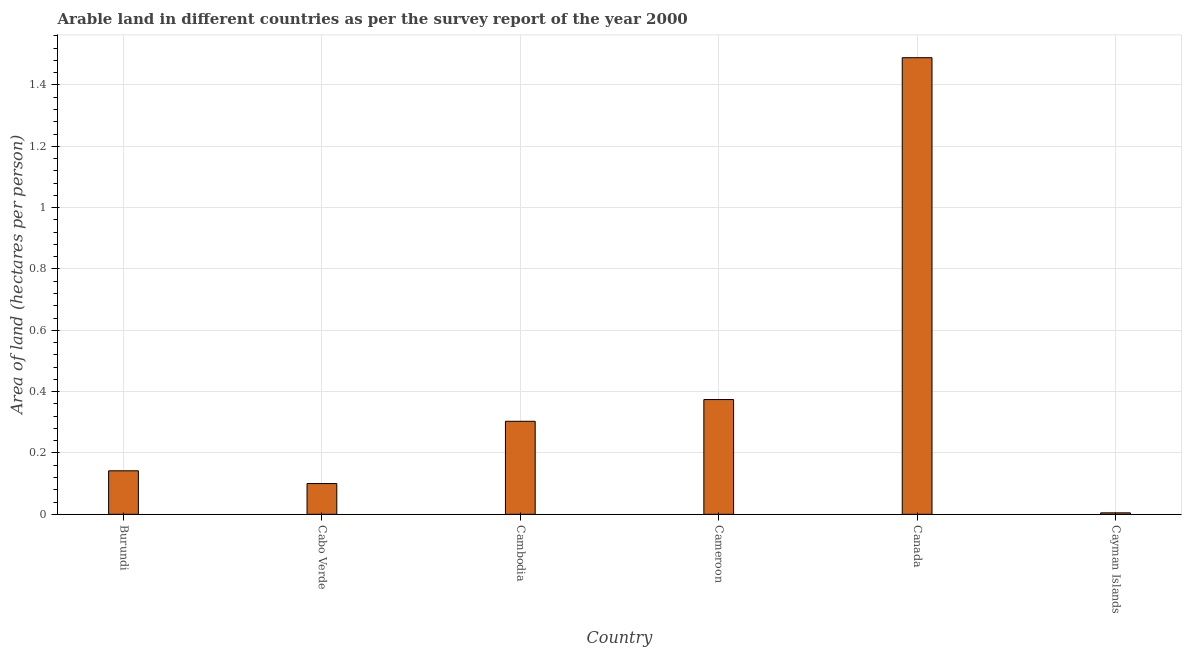Does the graph contain grids?
Keep it short and to the point. Yes. What is the title of the graph?
Offer a terse response. Arable land in different countries as per the survey report of the year 2000. What is the label or title of the X-axis?
Give a very brief answer. Country. What is the label or title of the Y-axis?
Your answer should be very brief. Area of land (hectares per person). What is the area of arable land in Cayman Islands?
Make the answer very short. 0. Across all countries, what is the maximum area of arable land?
Your response must be concise. 1.49. Across all countries, what is the minimum area of arable land?
Your answer should be very brief. 0. In which country was the area of arable land minimum?
Make the answer very short. Cayman Islands. What is the sum of the area of arable land?
Provide a short and direct response. 2.41. What is the difference between the area of arable land in Burundi and Cameroon?
Offer a very short reply. -0.23. What is the average area of arable land per country?
Offer a very short reply. 0.4. What is the median area of arable land?
Your answer should be compact. 0.22. In how many countries, is the area of arable land greater than 0.2 hectares per person?
Provide a short and direct response. 3. What is the ratio of the area of arable land in Cameroon to that in Canada?
Keep it short and to the point. 0.25. Is the area of arable land in Cambodia less than that in Cameroon?
Your response must be concise. Yes. Is the difference between the area of arable land in Burundi and Canada greater than the difference between any two countries?
Your response must be concise. No. What is the difference between the highest and the second highest area of arable land?
Ensure brevity in your answer.  1.11. Is the sum of the area of arable land in Cabo Verde and Cambodia greater than the maximum area of arable land across all countries?
Offer a very short reply. No. What is the difference between the highest and the lowest area of arable land?
Give a very brief answer. 1.48. Are all the bars in the graph horizontal?
Make the answer very short. No. Are the values on the major ticks of Y-axis written in scientific E-notation?
Give a very brief answer. No. What is the Area of land (hectares per person) in Burundi?
Offer a very short reply. 0.14. What is the Area of land (hectares per person) in Cabo Verde?
Provide a short and direct response. 0.1. What is the Area of land (hectares per person) of Cambodia?
Give a very brief answer. 0.3. What is the Area of land (hectares per person) of Cameroon?
Keep it short and to the point. 0.37. What is the Area of land (hectares per person) of Canada?
Your response must be concise. 1.49. What is the Area of land (hectares per person) of Cayman Islands?
Make the answer very short. 0. What is the difference between the Area of land (hectares per person) in Burundi and Cabo Verde?
Give a very brief answer. 0.04. What is the difference between the Area of land (hectares per person) in Burundi and Cambodia?
Give a very brief answer. -0.16. What is the difference between the Area of land (hectares per person) in Burundi and Cameroon?
Give a very brief answer. -0.23. What is the difference between the Area of land (hectares per person) in Burundi and Canada?
Your response must be concise. -1.35. What is the difference between the Area of land (hectares per person) in Burundi and Cayman Islands?
Give a very brief answer. 0.14. What is the difference between the Area of land (hectares per person) in Cabo Verde and Cambodia?
Provide a short and direct response. -0.2. What is the difference between the Area of land (hectares per person) in Cabo Verde and Cameroon?
Provide a succinct answer. -0.27. What is the difference between the Area of land (hectares per person) in Cabo Verde and Canada?
Offer a terse response. -1.39. What is the difference between the Area of land (hectares per person) in Cabo Verde and Cayman Islands?
Your answer should be very brief. 0.1. What is the difference between the Area of land (hectares per person) in Cambodia and Cameroon?
Ensure brevity in your answer.  -0.07. What is the difference between the Area of land (hectares per person) in Cambodia and Canada?
Provide a short and direct response. -1.19. What is the difference between the Area of land (hectares per person) in Cambodia and Cayman Islands?
Provide a short and direct response. 0.3. What is the difference between the Area of land (hectares per person) in Cameroon and Canada?
Offer a very short reply. -1.11. What is the difference between the Area of land (hectares per person) in Cameroon and Cayman Islands?
Your answer should be very brief. 0.37. What is the difference between the Area of land (hectares per person) in Canada and Cayman Islands?
Offer a terse response. 1.48. What is the ratio of the Area of land (hectares per person) in Burundi to that in Cabo Verde?
Your response must be concise. 1.42. What is the ratio of the Area of land (hectares per person) in Burundi to that in Cambodia?
Offer a terse response. 0.47. What is the ratio of the Area of land (hectares per person) in Burundi to that in Cameroon?
Your answer should be very brief. 0.38. What is the ratio of the Area of land (hectares per person) in Burundi to that in Canada?
Keep it short and to the point. 0.1. What is the ratio of the Area of land (hectares per person) in Burundi to that in Cayman Islands?
Offer a terse response. 29.57. What is the ratio of the Area of land (hectares per person) in Cabo Verde to that in Cambodia?
Your answer should be very brief. 0.33. What is the ratio of the Area of land (hectares per person) in Cabo Verde to that in Cameroon?
Keep it short and to the point. 0.27. What is the ratio of the Area of land (hectares per person) in Cabo Verde to that in Canada?
Ensure brevity in your answer.  0.07. What is the ratio of the Area of land (hectares per person) in Cabo Verde to that in Cayman Islands?
Ensure brevity in your answer.  20.9. What is the ratio of the Area of land (hectares per person) in Cambodia to that in Cameroon?
Offer a terse response. 0.81. What is the ratio of the Area of land (hectares per person) in Cambodia to that in Canada?
Provide a short and direct response. 0.2. What is the ratio of the Area of land (hectares per person) in Cambodia to that in Cayman Islands?
Make the answer very short. 63.22. What is the ratio of the Area of land (hectares per person) in Cameroon to that in Canada?
Ensure brevity in your answer.  0.25. What is the ratio of the Area of land (hectares per person) in Cameroon to that in Cayman Islands?
Your answer should be very brief. 77.99. What is the ratio of the Area of land (hectares per person) in Canada to that in Cayman Islands?
Keep it short and to the point. 310.3. 